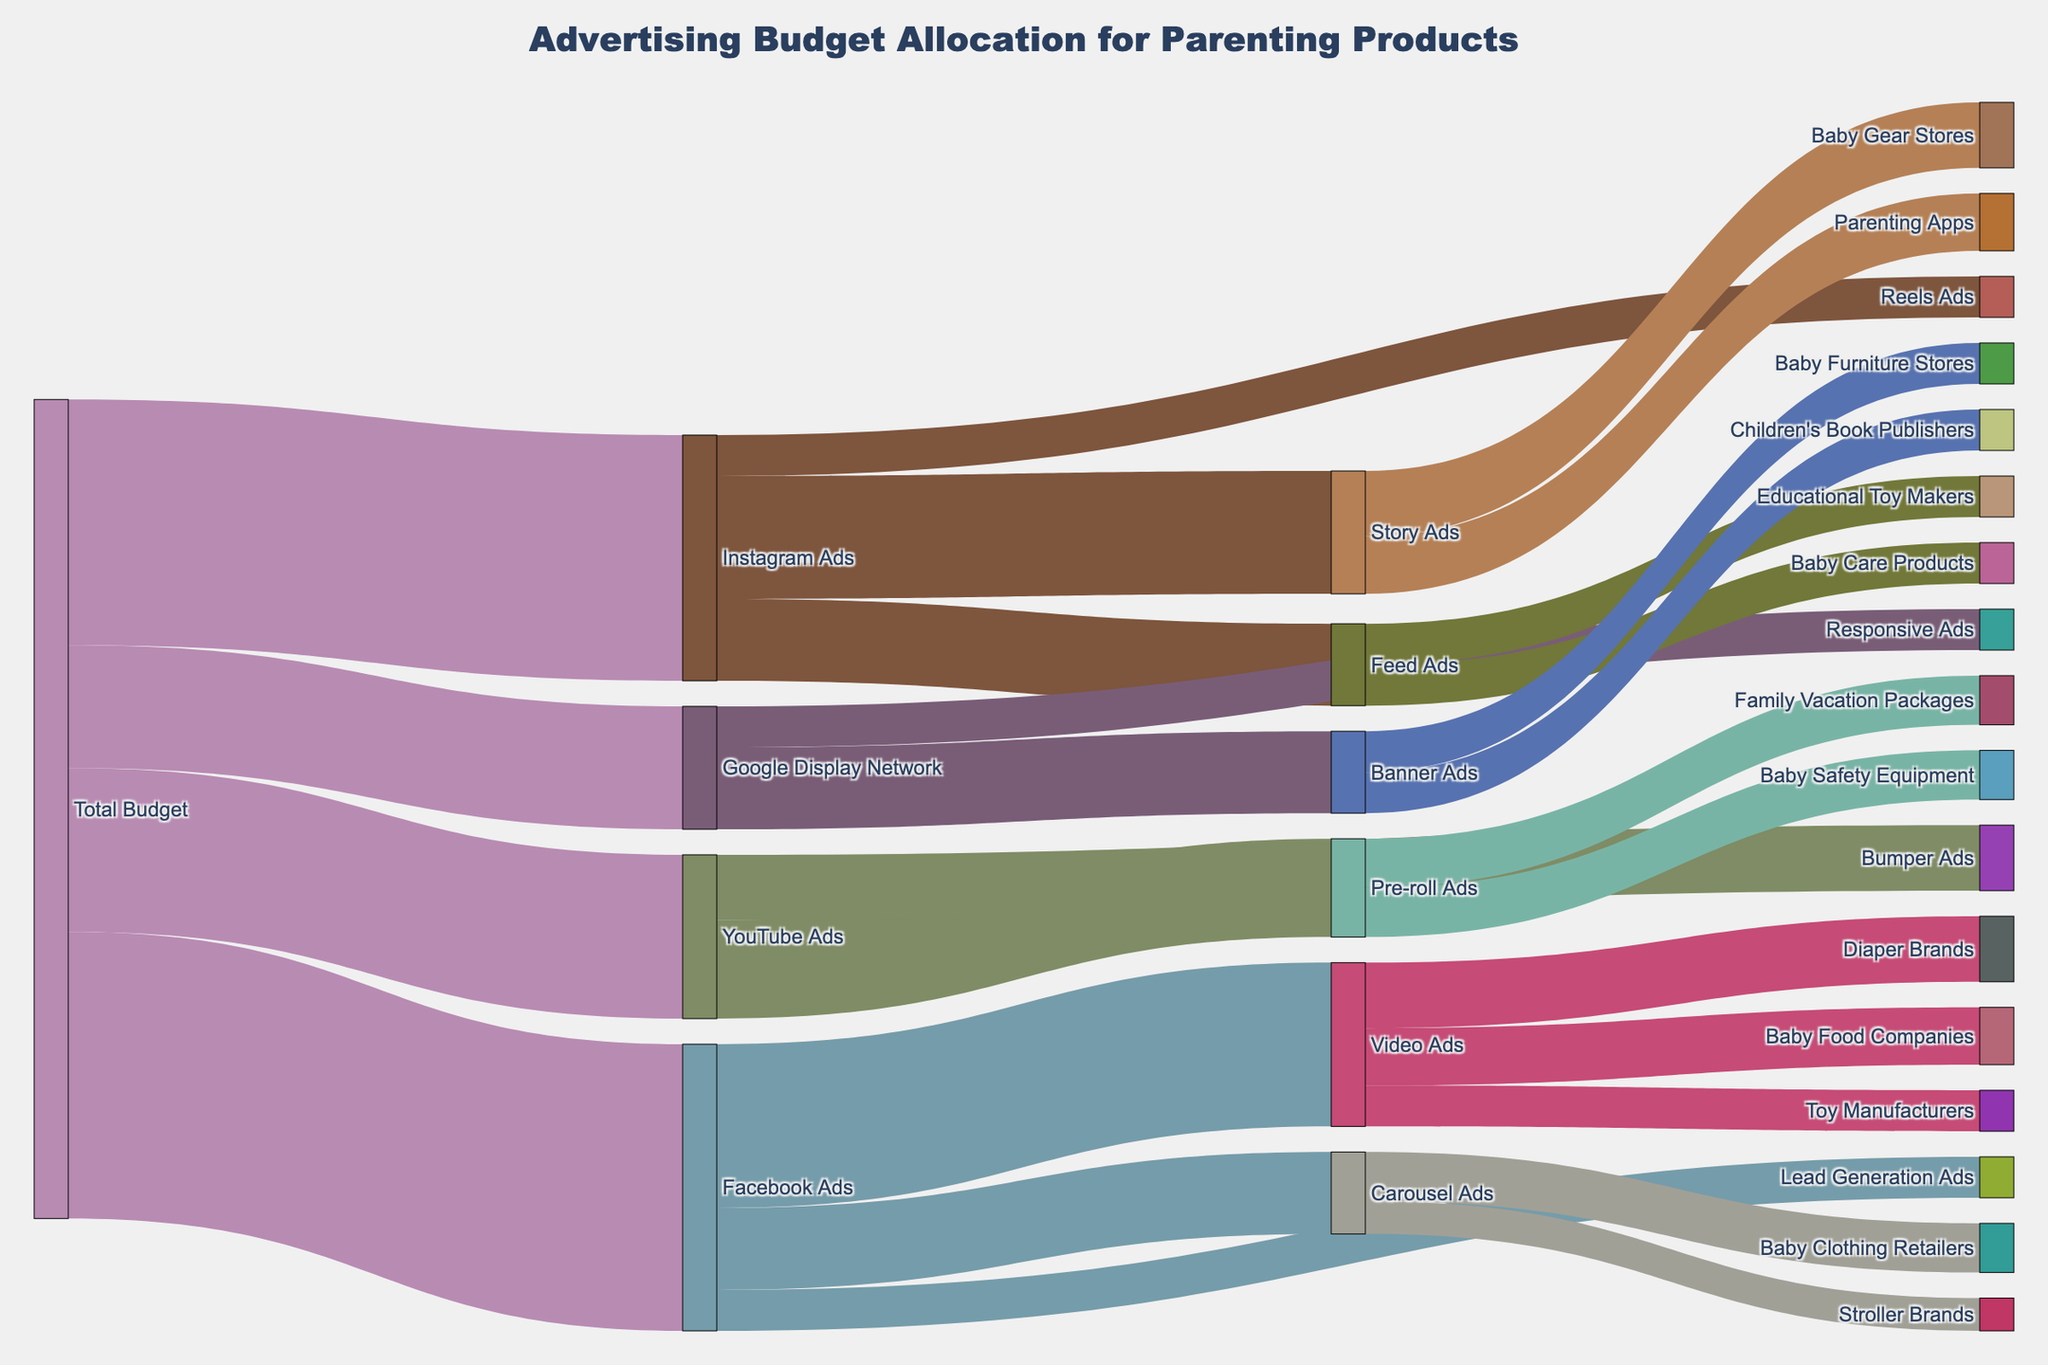Who received the largest portion of the total budget? By observing the thickness of the flows from the "Total Budget" node, we can see that "Facebook Ads" has the thickest flow, indicating it received the largest portion of the budget.
Answer: Facebook Ads What is the total budget allocated to Instagram Ads? The thickness of the flow from "Total Budget" to "Instagram Ads" indicates the budget allocation, which is labeled as 30 units.
Answer: 30 units Which type of Facebook Ad received the smallest allocation? From the "Facebook Ads" flows, we can see the flow to "Lead Generation Ads" is the thinnest and labeled as 5 units, indicating it received the smallest allocation.
Answer: Lead Generation Ads How much of the budget allocated to Google Display Network is used for Banner Ads? The flow from "Google Display Network" to "Banner Ads" shows the budget allocation, which is labeled as 10 units.
Answer: 10 units What is the total budget allocated to Video Ads and Carousel Ads under Facebook Ads? Adding the budget allocation for "Video Ads" (20 units) and "Carousel Ads" (10 units) under "Facebook Ads" gives 20 + 10 = 30 units.
Answer: 30 units Which YouTube Ad type received more budget, Pre-roll Ads or Bumper Ads? Comparing the thickness and labels of the flows from “YouTube Ads” to “Pre-roll Ads” (12 units) and “Bumper Ads” (8 units), Pre-roll Ads received more budget.
Answer: Pre-roll Ads What is the combined budget allocation for all Facebook Ads subtypes? Summing the allocations for "Video Ads" (20 units), "Carousel Ads" (10 units), and "Lead Generation Ads" (5 units) gives 20 + 10 + 5 = 35 units.
Answer: 35 units Which specific target received the smallest budget allocation across all channels? Looking at the smallest labeled flows in the diagram, "Reels Ads" under "Instagram Ads" and "Responsive Ads" under "Google Display Network" each received 5 units. Along with "Lead Generation Ads" under "Facebook Ads", this is the smallest allocation. Among the specific targets under these, "Diaper Brands" under "Video Ads" and several others also received 5 units. We can mention any one of these specific targets equally.
Answer: Diaper Brands (or any other specific target receiving 5 units) What is the total budget allocated to Baby Food Companies through all ad types? Baby Food Companies received 7 units through "Video Ads". No other ad types specify allocations to Baby Food Companies.
Answer: 7 units 